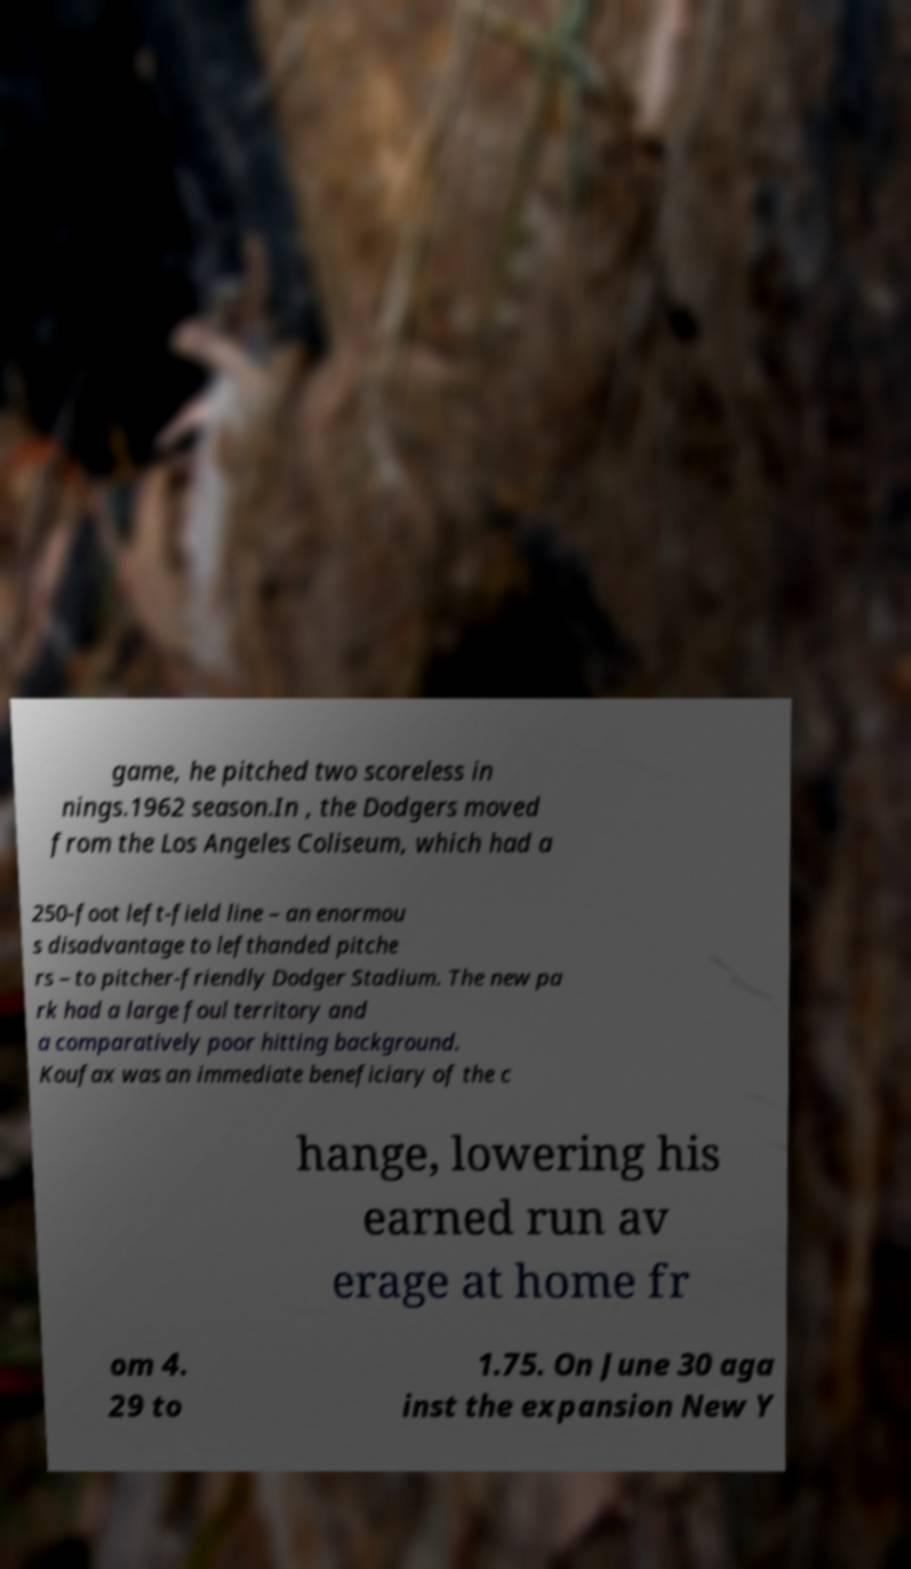Can you accurately transcribe the text from the provided image for me? game, he pitched two scoreless in nings.1962 season.In , the Dodgers moved from the Los Angeles Coliseum, which had a 250-foot left-field line – an enormou s disadvantage to lefthanded pitche rs – to pitcher-friendly Dodger Stadium. The new pa rk had a large foul territory and a comparatively poor hitting background. Koufax was an immediate beneficiary of the c hange, lowering his earned run av erage at home fr om 4. 29 to 1.75. On June 30 aga inst the expansion New Y 